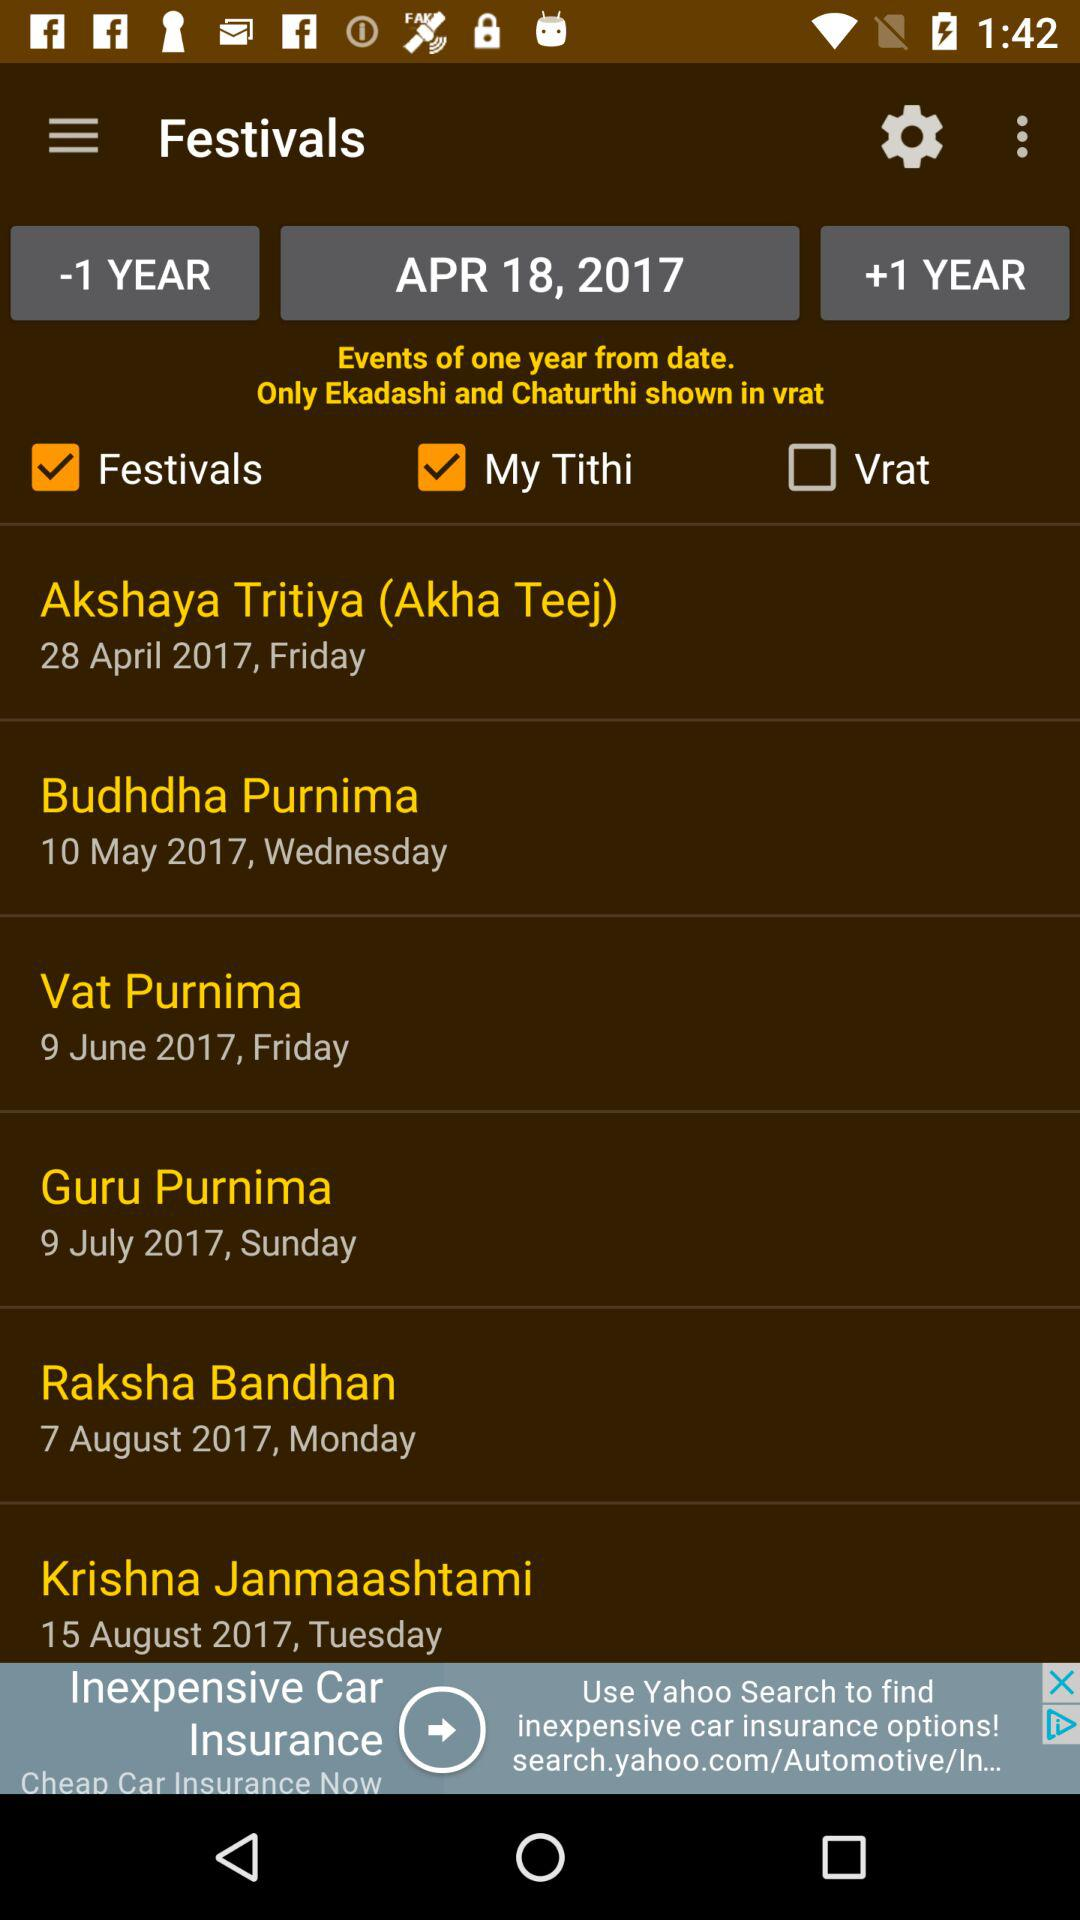On which date can we celebrate Guru Purnima? You can celebrate Guru Purnima on Sunday, July 9, 2017. 